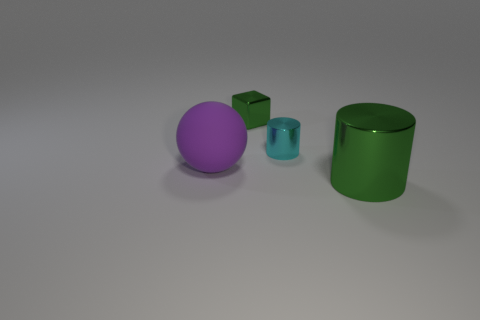Add 3 large green objects. How many objects exist? 7 Subtract all spheres. How many objects are left? 3 Add 3 small cyan metallic cylinders. How many small cyan metallic cylinders are left? 4 Add 2 brown balls. How many brown balls exist? 2 Subtract 0 red cylinders. How many objects are left? 4 Subtract all green metal things. Subtract all purple things. How many objects are left? 1 